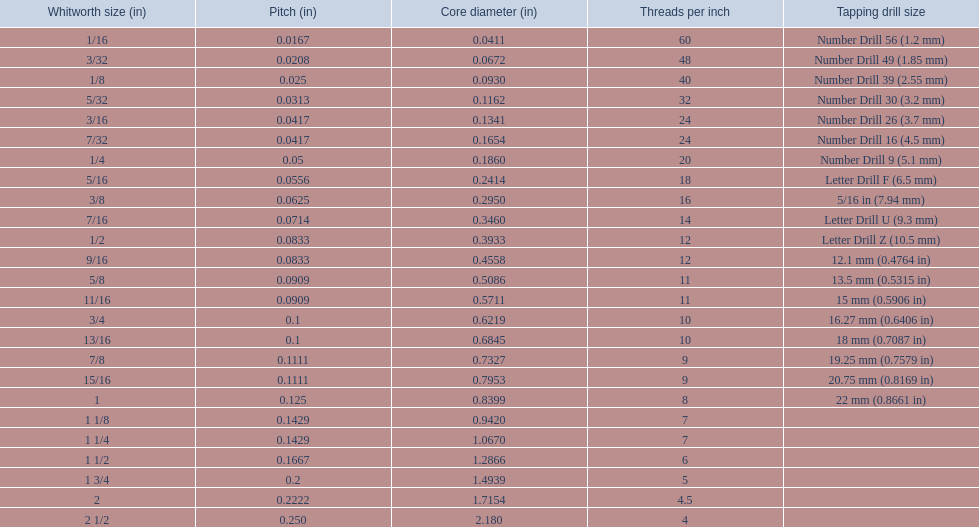What was the core diameter of a number drill 26 0.1341. What is this measurement in whitworth size? 3/16. 